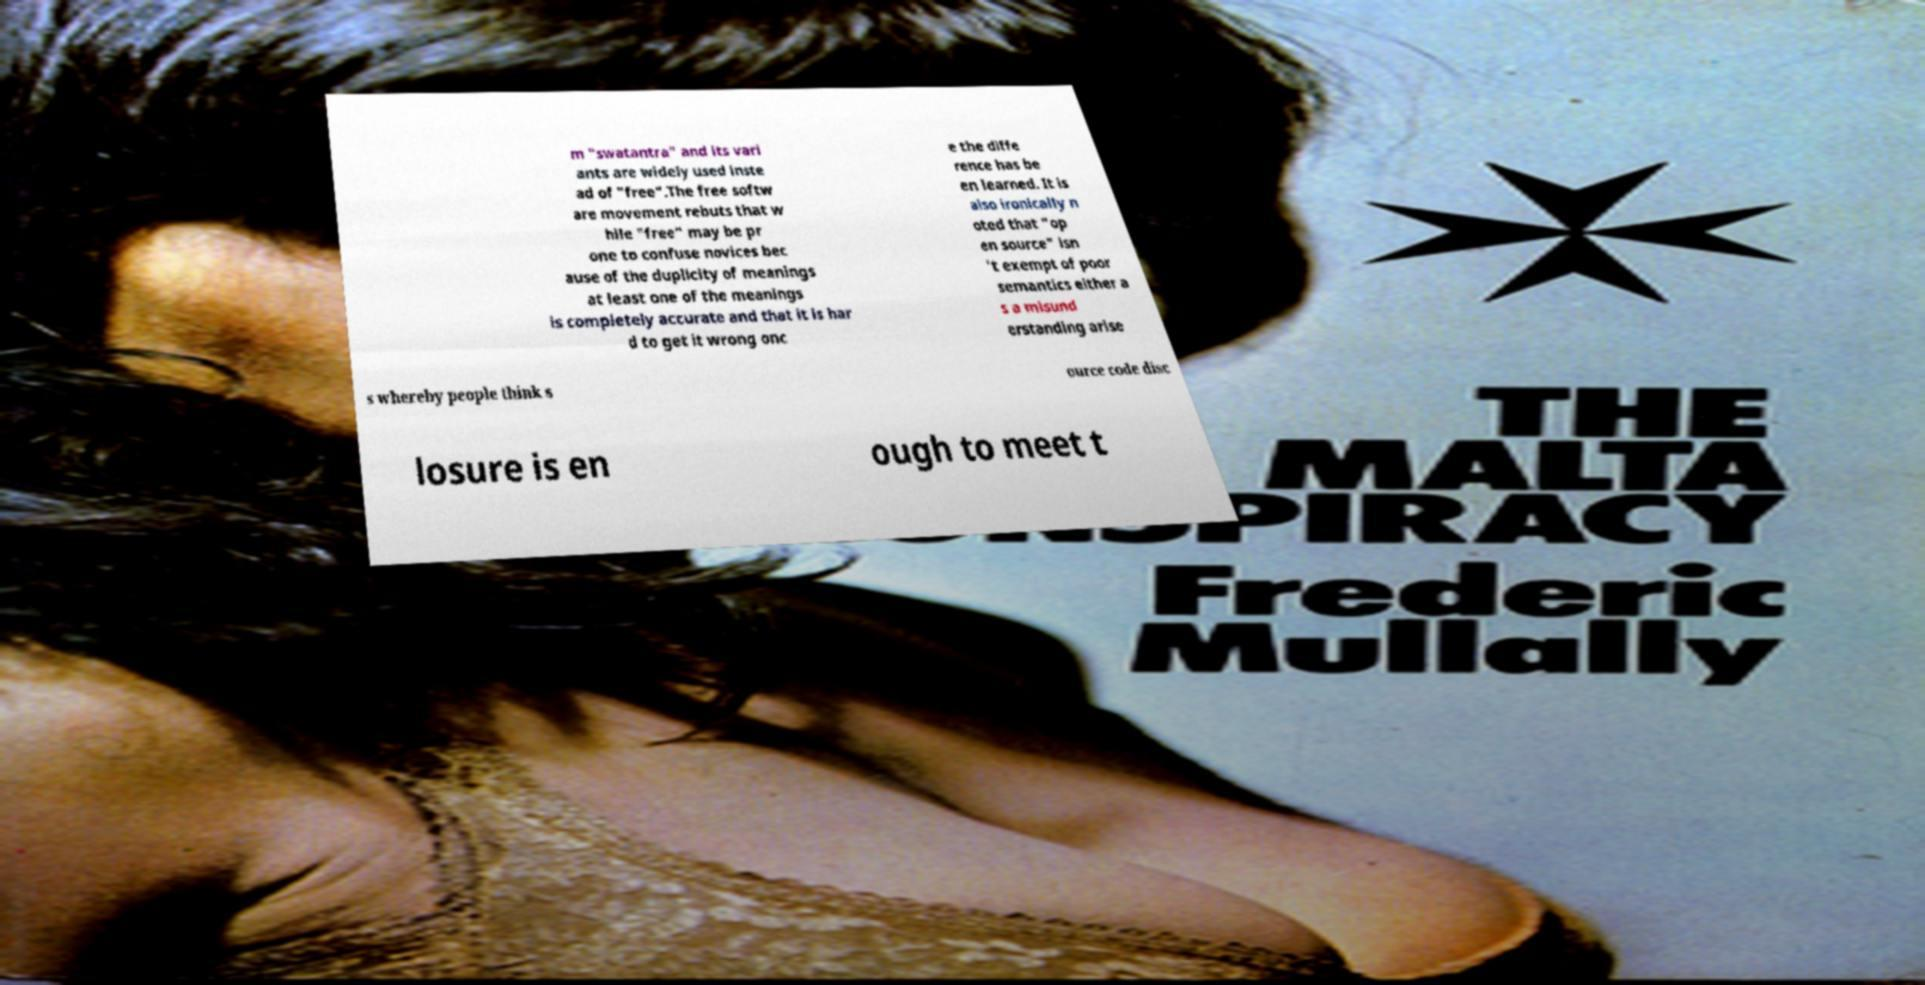Please read and relay the text visible in this image. What does it say? m "swatantra" and its vari ants are widely used inste ad of "free".The free softw are movement rebuts that w hile "free" may be pr one to confuse novices bec ause of the duplicity of meanings at least one of the meanings is completely accurate and that it is har d to get it wrong onc e the diffe rence has be en learned. It is also ironically n oted that "op en source" isn 't exempt of poor semantics either a s a misund erstanding arise s whereby people think s ource code disc losure is en ough to meet t 